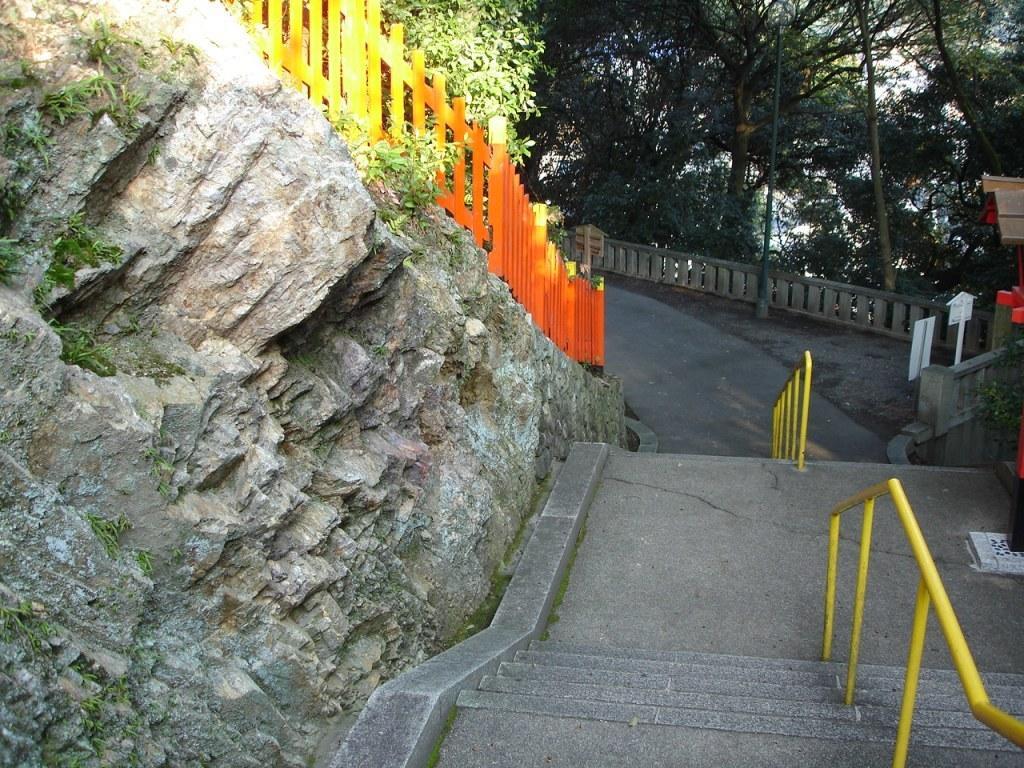In one or two sentences, can you explain what this image depicts? In this image we can see a wooden fencing, stairs, sign board and trees. 